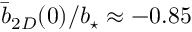<formula> <loc_0><loc_0><loc_500><loc_500>\bar { b } _ { 2 D } ( 0 ) / { b _ { ^ { * } } } \approx - 0 . 8 5</formula> 